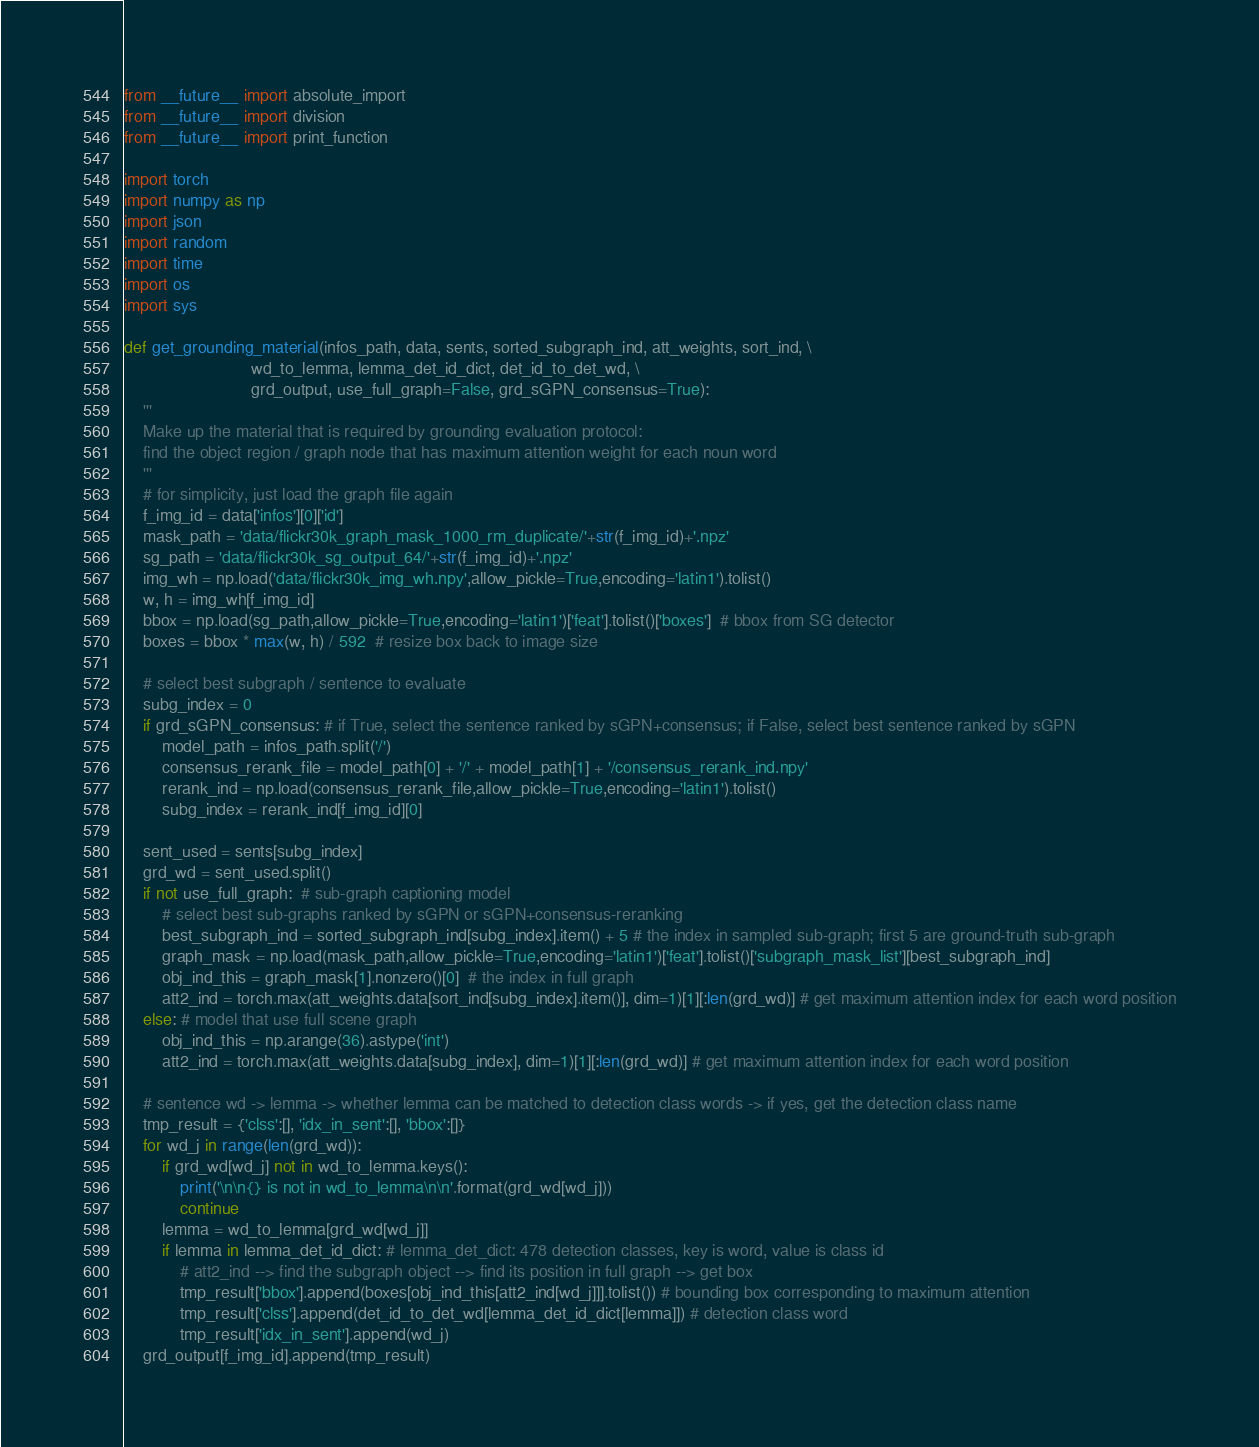Convert code to text. <code><loc_0><loc_0><loc_500><loc_500><_Python_>from __future__ import absolute_import
from __future__ import division
from __future__ import print_function

import torch
import numpy as np
import json
import random
import time
import os
import sys

def get_grounding_material(infos_path, data, sents, sorted_subgraph_ind, att_weights, sort_ind, \
                           wd_to_lemma, lemma_det_id_dict, det_id_to_det_wd, \
                           grd_output, use_full_graph=False, grd_sGPN_consensus=True):
    '''
    Make up the material that is required by grounding evaluation protocol:
    find the object region / graph node that has maximum attention weight for each noun word
    '''
    # for simplicity, just load the graph file again
    f_img_id = data['infos'][0]['id']
    mask_path = 'data/flickr30k_graph_mask_1000_rm_duplicate/'+str(f_img_id)+'.npz'
    sg_path = 'data/flickr30k_sg_output_64/'+str(f_img_id)+'.npz'
    img_wh = np.load('data/flickr30k_img_wh.npy',allow_pickle=True,encoding='latin1').tolist()
    w, h = img_wh[f_img_id]
    bbox = np.load(sg_path,allow_pickle=True,encoding='latin1')['feat'].tolist()['boxes']  # bbox from SG detector
    boxes = bbox * max(w, h) / 592  # resize box back to image size

    # select best subgraph / sentence to evaluate
    subg_index = 0
    if grd_sGPN_consensus: # if True, select the sentence ranked by sGPN+consensus; if False, select best sentence ranked by sGPN
        model_path = infos_path.split('/')
        consensus_rerank_file = model_path[0] + '/' + model_path[1] + '/consensus_rerank_ind.npy'
        rerank_ind = np.load(consensus_rerank_file,allow_pickle=True,encoding='latin1').tolist()
        subg_index = rerank_ind[f_img_id][0]

    sent_used = sents[subg_index]
    grd_wd = sent_used.split()    
    if not use_full_graph:  # sub-graph captioning model
        # select best sub-graphs ranked by sGPN or sGPN+consensus-reranking
        best_subgraph_ind = sorted_subgraph_ind[subg_index].item() + 5 # the index in sampled sub-graph; first 5 are ground-truth sub-graph
        graph_mask = np.load(mask_path,allow_pickle=True,encoding='latin1')['feat'].tolist()['subgraph_mask_list'][best_subgraph_ind]
        obj_ind_this = graph_mask[1].nonzero()[0]  # the index in full graph
        att2_ind = torch.max(att_weights.data[sort_ind[subg_index].item()], dim=1)[1][:len(grd_wd)] # get maximum attention index for each word position
    else: # model that use full scene graph
        obj_ind_this = np.arange(36).astype('int')
        att2_ind = torch.max(att_weights.data[subg_index], dim=1)[1][:len(grd_wd)] # get maximum attention index for each word position          
 
    # sentence wd -> lemma -> whether lemma can be matched to detection class words -> if yes, get the detection class name
    tmp_result = {'clss':[], 'idx_in_sent':[], 'bbox':[]}
    for wd_j in range(len(grd_wd)):
        if grd_wd[wd_j] not in wd_to_lemma.keys(): 
            print('\n\n{} is not in wd_to_lemma\n\n'.format(grd_wd[wd_j]))
            continue
        lemma = wd_to_lemma[grd_wd[wd_j]]
        if lemma in lemma_det_id_dict: # lemma_det_dict: 478 detection classes, key is word, value is class id
            # att2_ind --> find the subgraph object --> find its position in full graph --> get box
            tmp_result['bbox'].append(boxes[obj_ind_this[att2_ind[wd_j]]].tolist()) # bounding box corresponding to maximum attention
            tmp_result['clss'].append(det_id_to_det_wd[lemma_det_id_dict[lemma]]) # detection class word
            tmp_result['idx_in_sent'].append(wd_j)
    grd_output[f_img_id].append(tmp_result)</code> 